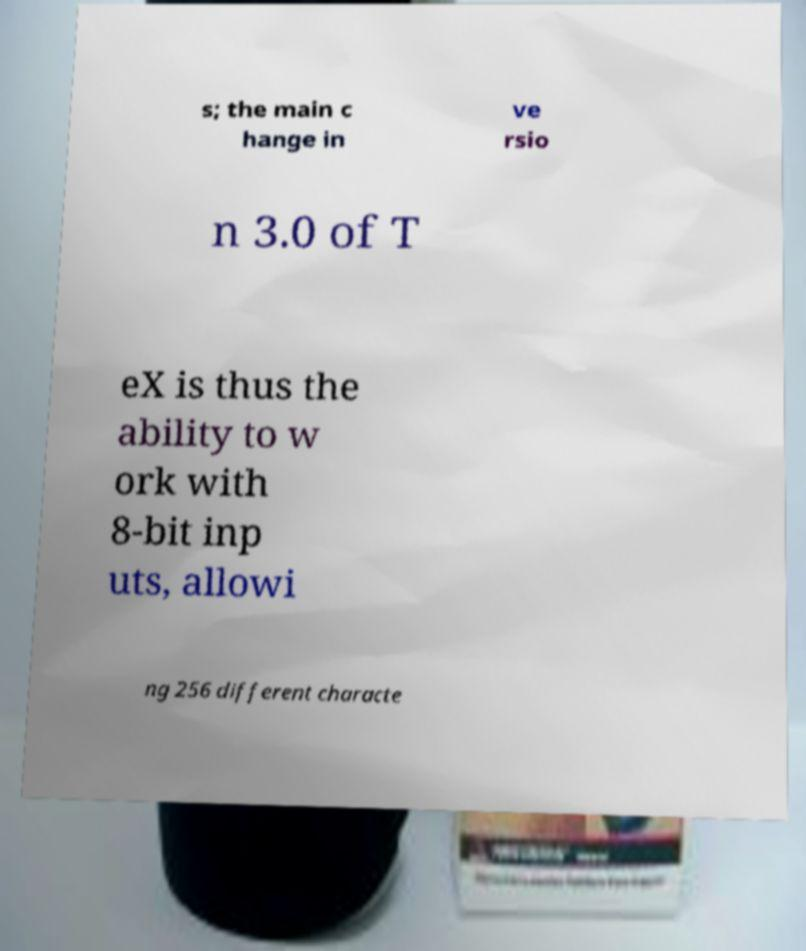Can you accurately transcribe the text from the provided image for me? s; the main c hange in ve rsio n 3.0 of T eX is thus the ability to w ork with 8-bit inp uts, allowi ng 256 different characte 